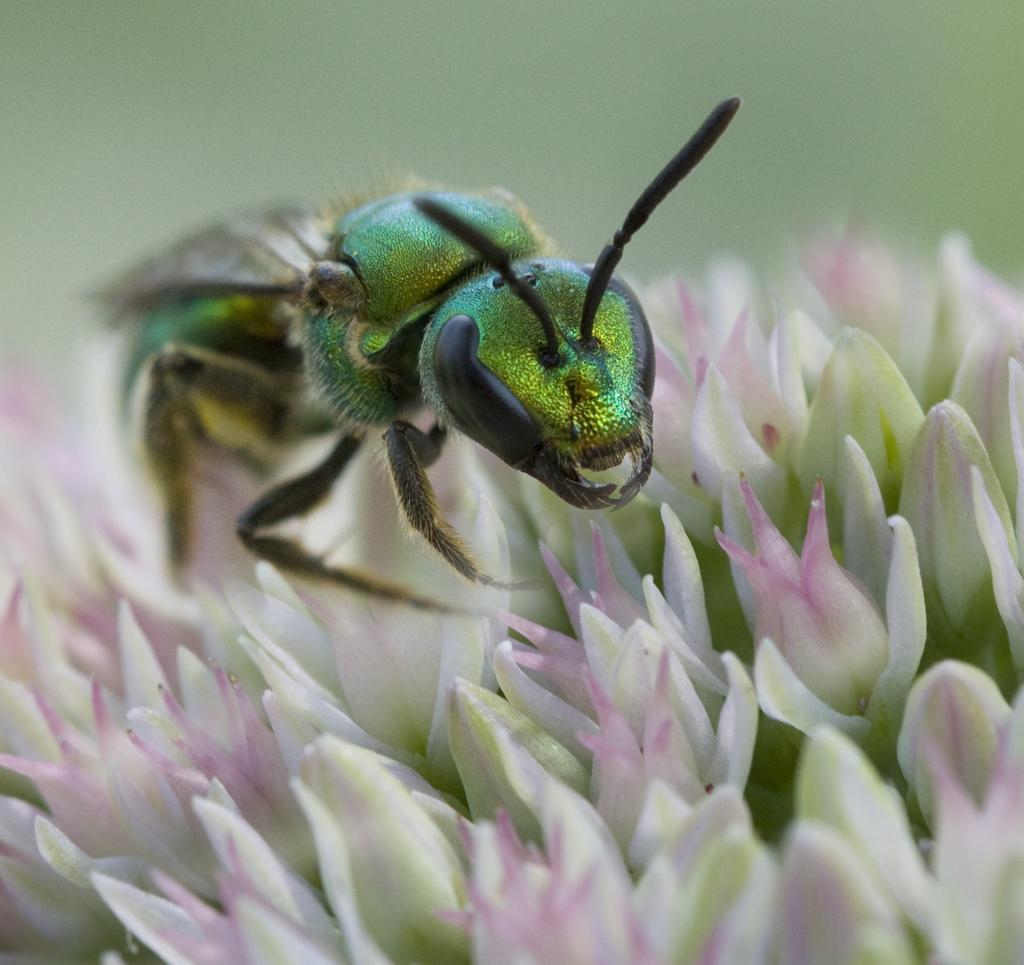Describe this image in one or two sentences. In the picture it is a zoom in picture of an insect which is laying on the flowers. 